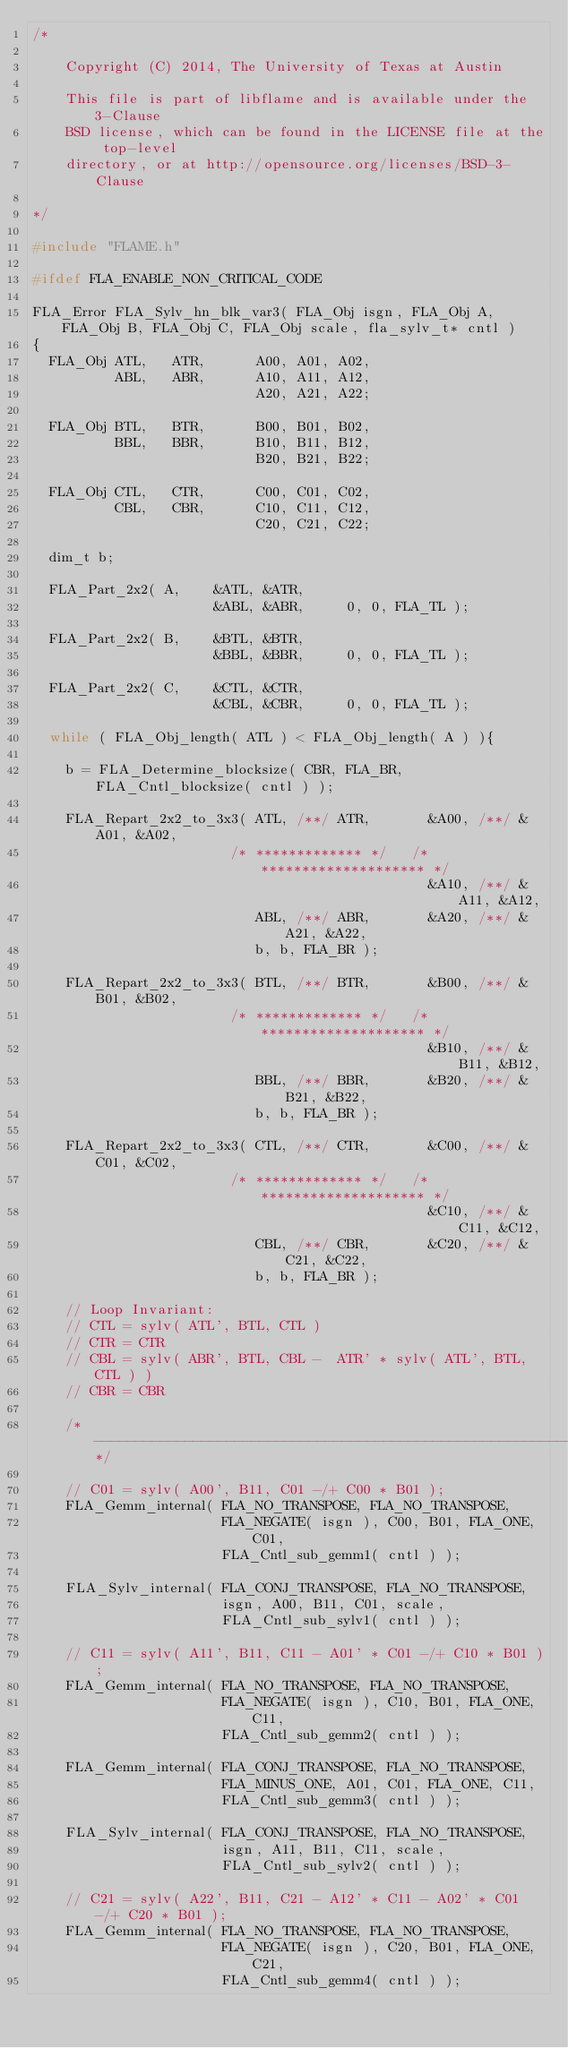Convert code to text. <code><loc_0><loc_0><loc_500><loc_500><_C_>/*

    Copyright (C) 2014, The University of Texas at Austin

    This file is part of libflame and is available under the 3-Clause
    BSD license, which can be found in the LICENSE file at the top-level
    directory, or at http://opensource.org/licenses/BSD-3-Clause

*/

#include "FLAME.h"

#ifdef FLA_ENABLE_NON_CRITICAL_CODE

FLA_Error FLA_Sylv_hn_blk_var3( FLA_Obj isgn, FLA_Obj A, FLA_Obj B, FLA_Obj C, FLA_Obj scale, fla_sylv_t* cntl )
{
  FLA_Obj ATL,   ATR,      A00, A01, A02, 
          ABL,   ABR,      A10, A11, A12,
                           A20, A21, A22;

  FLA_Obj BTL,   BTR,      B00, B01, B02, 
          BBL,   BBR,      B10, B11, B12,
                           B20, B21, B22;

  FLA_Obj CTL,   CTR,      C00, C01, C02, 
          CBL,   CBR,      C10, C11, C12,
                           C20, C21, C22;

  dim_t b;

  FLA_Part_2x2( A,    &ATL, &ATR,
                      &ABL, &ABR,     0, 0, FLA_TL );

  FLA_Part_2x2( B,    &BTL, &BTR,
                      &BBL, &BBR,     0, 0, FLA_TL );

  FLA_Part_2x2( C,    &CTL, &CTR,
                      &CBL, &CBR,     0, 0, FLA_TL );

  while ( FLA_Obj_length( ATL ) < FLA_Obj_length( A ) ){

    b = FLA_Determine_blocksize( CBR, FLA_BR, FLA_Cntl_blocksize( cntl ) );

    FLA_Repart_2x2_to_3x3( ATL, /**/ ATR,       &A00, /**/ &A01, &A02,
                        /* ************* */   /* ******************** */
                                                &A10, /**/ &A11, &A12,
                           ABL, /**/ ABR,       &A20, /**/ &A21, &A22,
                           b, b, FLA_BR );

    FLA_Repart_2x2_to_3x3( BTL, /**/ BTR,       &B00, /**/ &B01, &B02,
                        /* ************* */   /* ******************** */
                                                &B10, /**/ &B11, &B12,
                           BBL, /**/ BBR,       &B20, /**/ &B21, &B22,
                           b, b, FLA_BR );

    FLA_Repart_2x2_to_3x3( CTL, /**/ CTR,       &C00, /**/ &C01, &C02,
                        /* ************* */   /* ******************** */
                                                &C10, /**/ &C11, &C12,
                           CBL, /**/ CBR,       &C20, /**/ &C21, &C22,
                           b, b, FLA_BR );

    // Loop Invariant:
    // CTL = sylv( ATL', BTL, CTL )
    // CTR = CTR
    // CBL = sylv( ABR', BTL, CBL -  ATR' * sylv( ATL', BTL, CTL ) )
    // CBR = CBR

    /*------------------------------------------------------------*/

    // C01 = sylv( A00', B11, C01 -/+ C00 * B01 );
    FLA_Gemm_internal( FLA_NO_TRANSPOSE, FLA_NO_TRANSPOSE,
                       FLA_NEGATE( isgn ), C00, B01, FLA_ONE, C01,
                       FLA_Cntl_sub_gemm1( cntl ) );

    FLA_Sylv_internal( FLA_CONJ_TRANSPOSE, FLA_NO_TRANSPOSE, 
                       isgn, A00, B11, C01, scale,
                       FLA_Cntl_sub_sylv1( cntl ) );

    // C11 = sylv( A11', B11, C11 - A01' * C01 -/+ C10 * B01 );
    FLA_Gemm_internal( FLA_NO_TRANSPOSE, FLA_NO_TRANSPOSE,
                       FLA_NEGATE( isgn ), C10, B01, FLA_ONE, C11,
                       FLA_Cntl_sub_gemm2( cntl ) );

    FLA_Gemm_internal( FLA_CONJ_TRANSPOSE, FLA_NO_TRANSPOSE,
                       FLA_MINUS_ONE, A01, C01, FLA_ONE, C11,
                       FLA_Cntl_sub_gemm3( cntl ) );

    FLA_Sylv_internal( FLA_CONJ_TRANSPOSE, FLA_NO_TRANSPOSE, 
                       isgn, A11, B11, C11, scale,
                       FLA_Cntl_sub_sylv2( cntl ) );

    // C21 = sylv( A22', B11, C21 - A12' * C11 - A02' * C01 -/+ C20 * B01 );
    FLA_Gemm_internal( FLA_NO_TRANSPOSE, FLA_NO_TRANSPOSE,
                       FLA_NEGATE( isgn ), C20, B01, FLA_ONE, C21,
                       FLA_Cntl_sub_gemm4( cntl ) );
</code> 